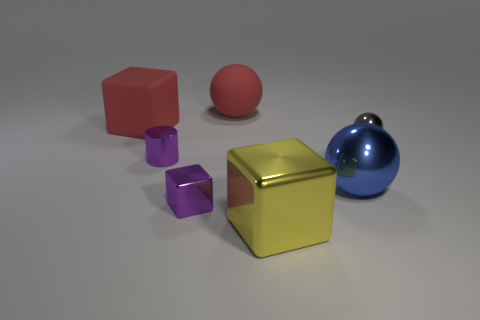Add 2 large yellow things. How many objects exist? 9 Subtract all cubes. How many objects are left? 4 Add 1 yellow metal cylinders. How many yellow metal cylinders exist? 1 Subtract 0 brown blocks. How many objects are left? 7 Subtract all purple shiny cylinders. Subtract all blue objects. How many objects are left? 5 Add 3 red cubes. How many red cubes are left? 4 